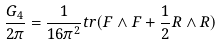<formula> <loc_0><loc_0><loc_500><loc_500>\frac { G _ { 4 } } { 2 \pi } = \frac { 1 } { 1 6 \pi ^ { 2 } } t r ( F \wedge F + \frac { 1 } { 2 } R \wedge R )</formula> 